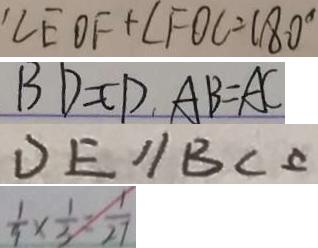<formula> <loc_0><loc_0><loc_500><loc_500>\angle E O F + \angle F O C = 1 8 0 ^ { \circ } 
 B D = C D , A B = A C 
 D E / / B C 
 \frac { 1 } { 9 } \times \frac { 1 } { 3 } = \frac { 1 } { 2 7 }</formula> 